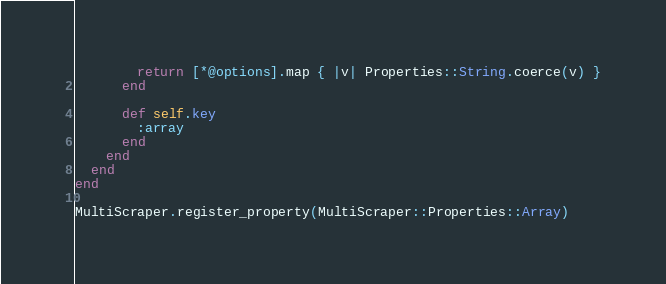<code> <loc_0><loc_0><loc_500><loc_500><_Ruby_>        return [*@options].map { |v| Properties::String.coerce(v) }
      end

      def self.key
        :array
      end
    end
  end
end

MultiScraper.register_property(MultiScraper::Properties::Array)
</code> 